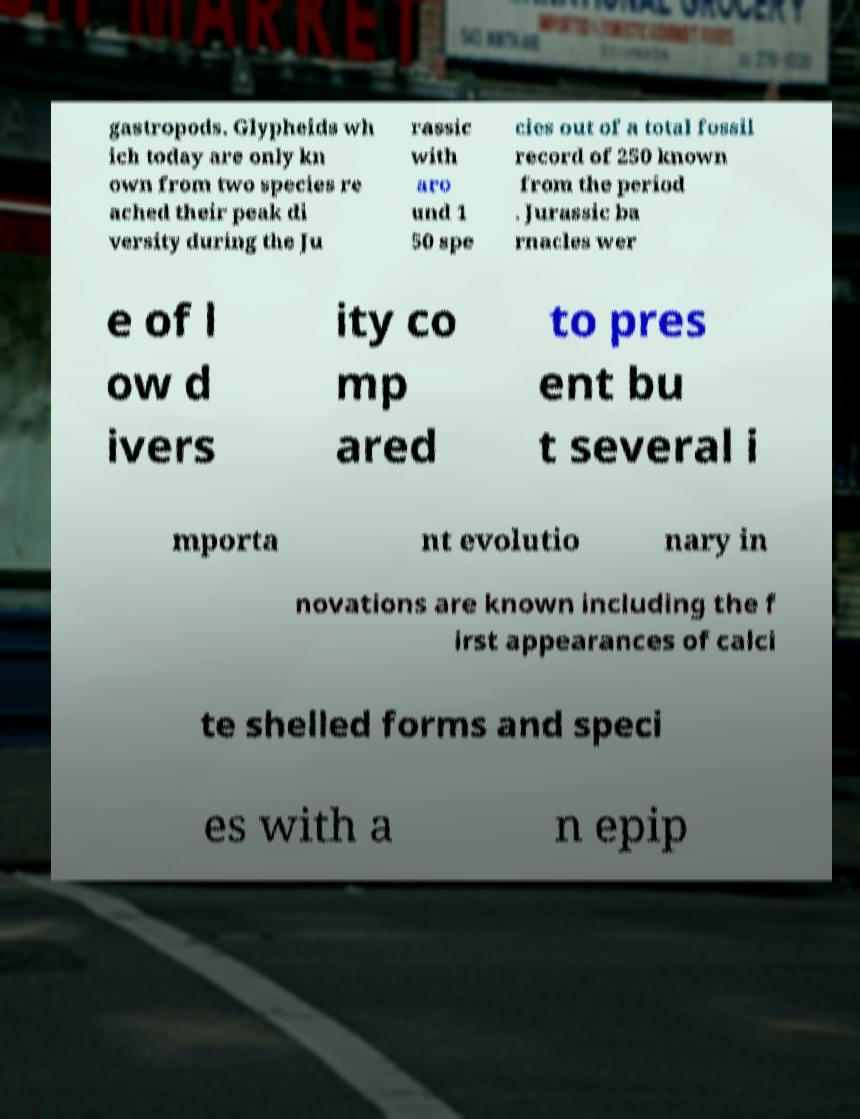Could you assist in decoding the text presented in this image and type it out clearly? gastropods. Glypheids wh ich today are only kn own from two species re ached their peak di versity during the Ju rassic with aro und 1 50 spe cies out of a total fossil record of 250 known from the period . Jurassic ba rnacles wer e of l ow d ivers ity co mp ared to pres ent bu t several i mporta nt evolutio nary in novations are known including the f irst appearances of calci te shelled forms and speci es with a n epip 